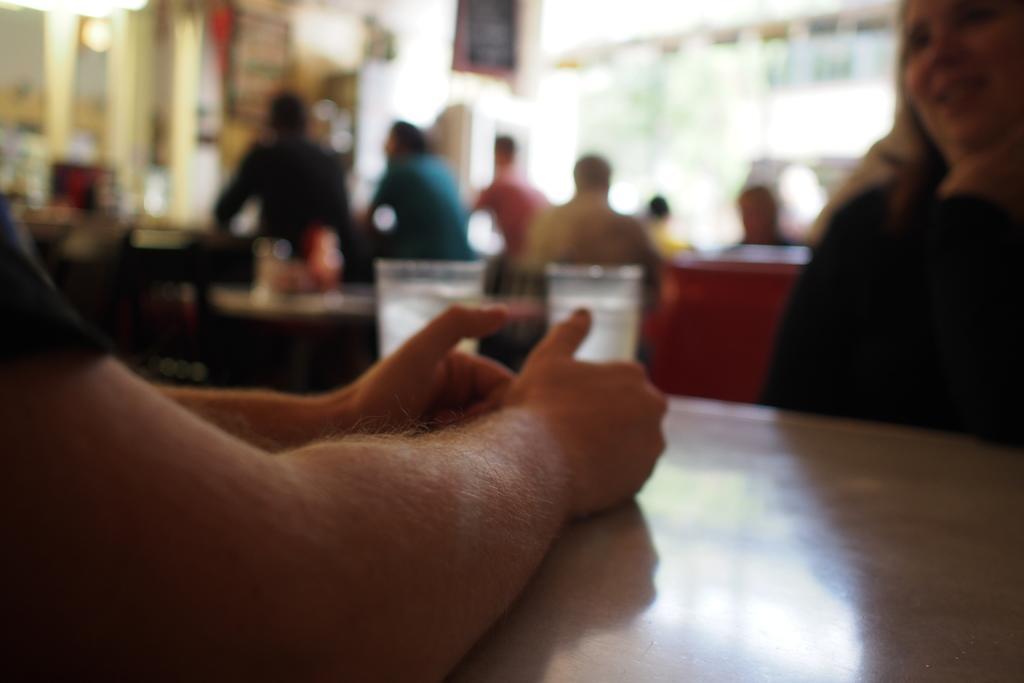In one or two sentences, can you explain what this image depicts? In this image there are many tables and chairs. Few people are there. On the left there are two hands. The picture is blur. 